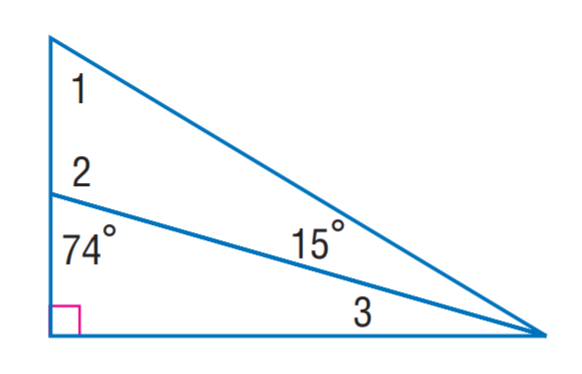Answer the mathemtical geometry problem and directly provide the correct option letter.
Question: Find m \angle 2.
Choices: A: 59 B: 74 C: 106 D: 110 C 